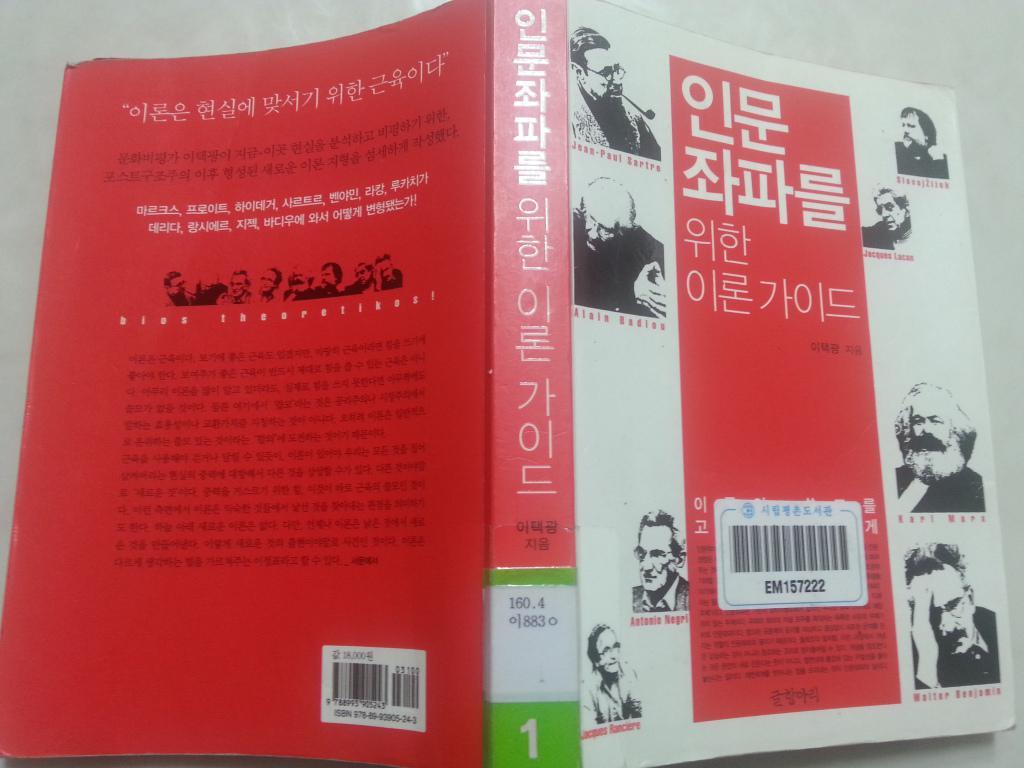What number is in green on the spine?
Offer a very short reply. 1. 